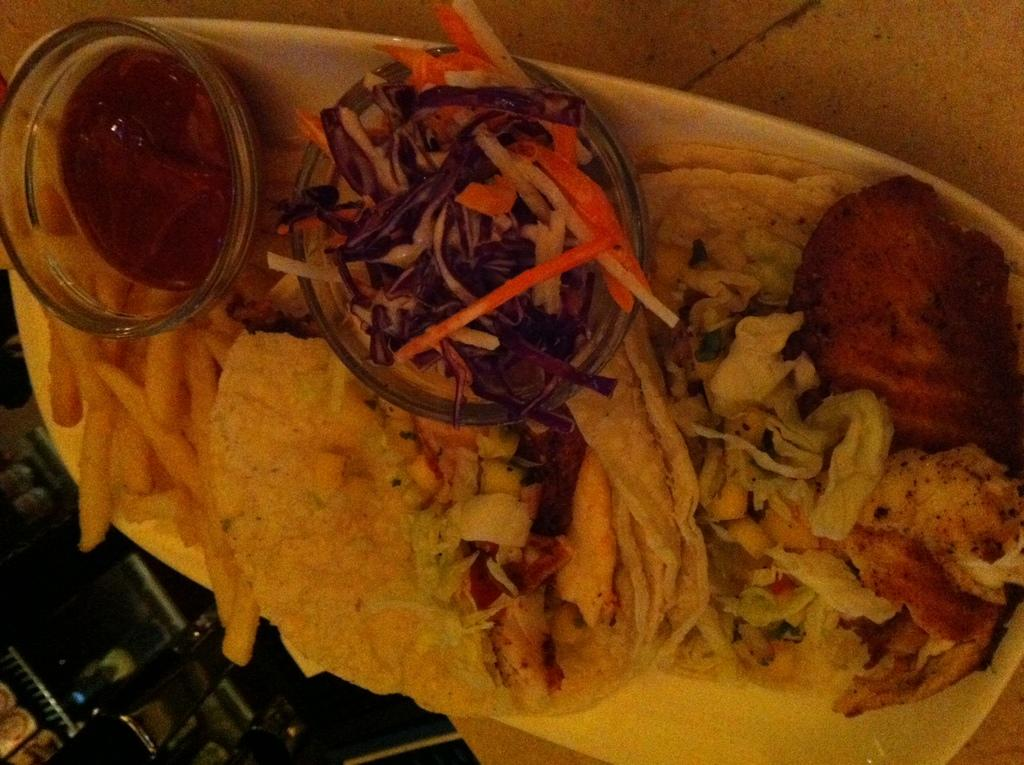What is on the plate that is visible in the image? There are food items arranged on a plate in the image. What color is the plate? The plate is white in color. Where is the plate located in the image? The plate is placed on a table in the image. What else can be seen in the background of the image? There are other objects in the background of the image. What theory is being discussed by the lake in the image? There is no lake or discussion of a theory present in the image. What attraction is visible in the background of the image? The facts provided do not mention any attractions in the background of the image. 